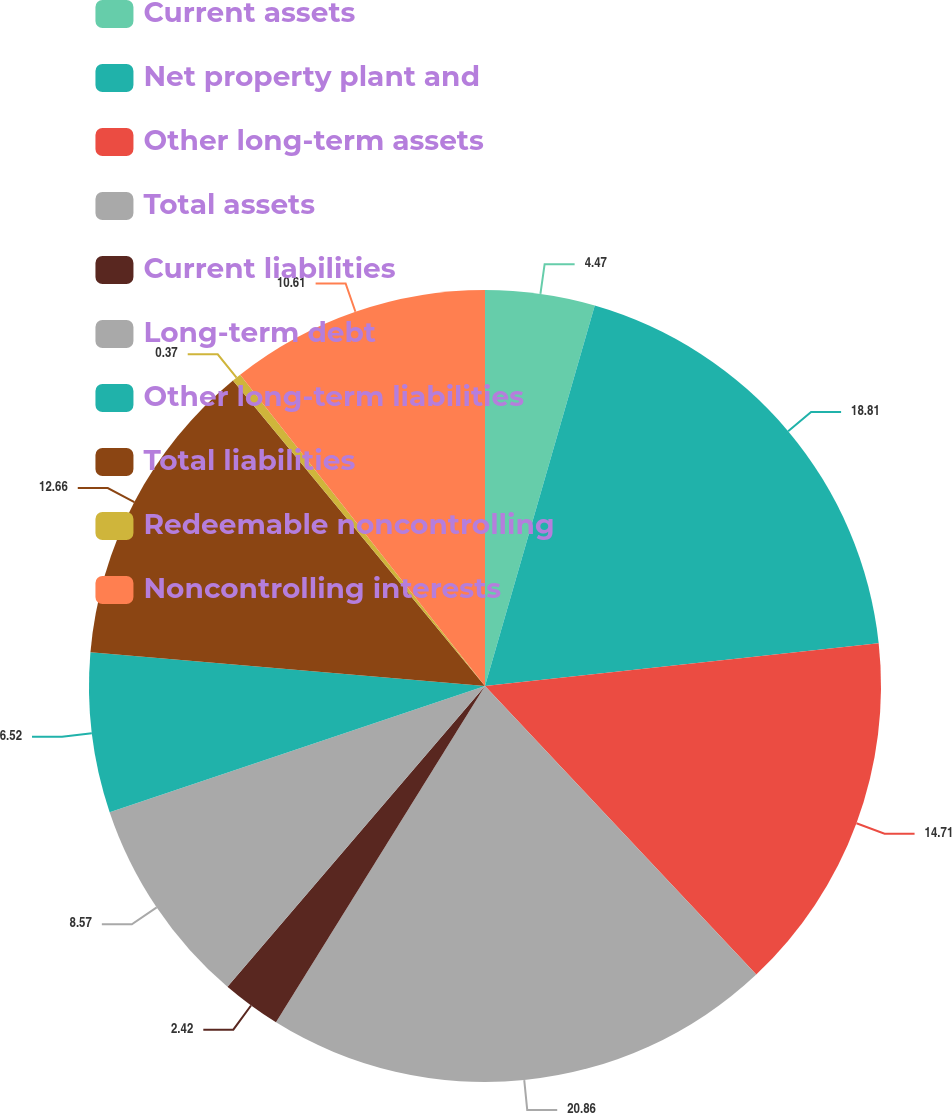Convert chart to OTSL. <chart><loc_0><loc_0><loc_500><loc_500><pie_chart><fcel>Current assets<fcel>Net property plant and<fcel>Other long-term assets<fcel>Total assets<fcel>Current liabilities<fcel>Long-term debt<fcel>Other long-term liabilities<fcel>Total liabilities<fcel>Redeemable noncontrolling<fcel>Noncontrolling interests<nl><fcel>4.47%<fcel>18.81%<fcel>14.71%<fcel>20.86%<fcel>2.42%<fcel>8.57%<fcel>6.52%<fcel>12.66%<fcel>0.37%<fcel>10.61%<nl></chart> 